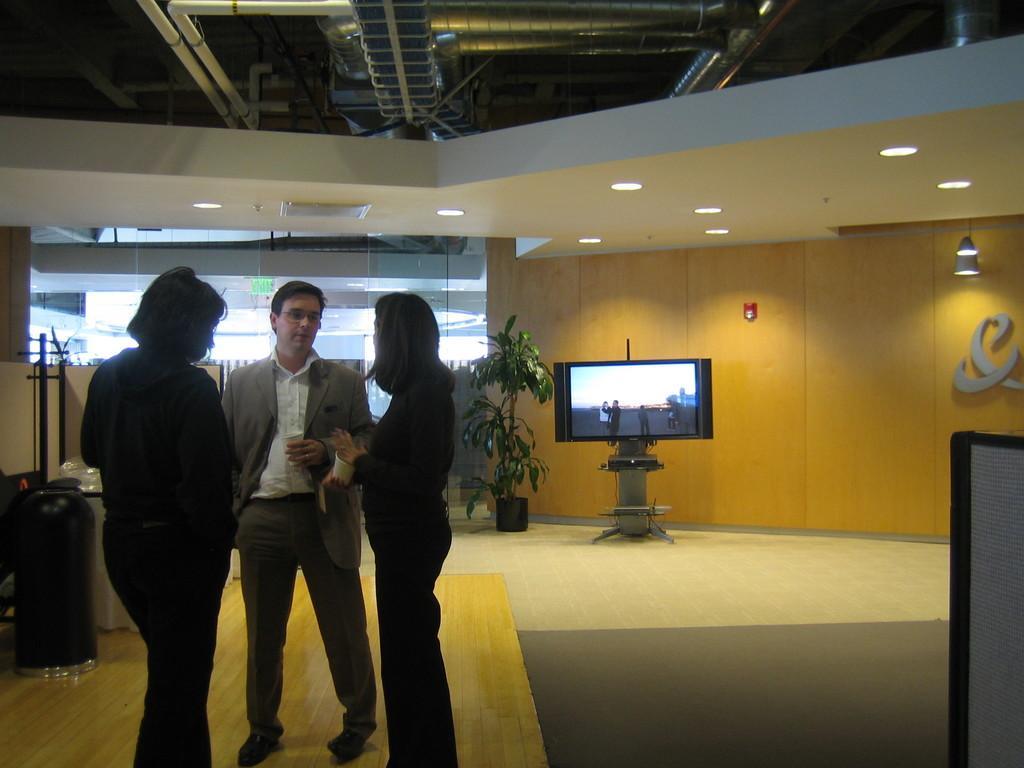Please provide a concise description of this image. In this image we can see three people standing. In the background of the image there is glass. There is a plant. There is a TV. At the bottom of the image there is carpet. At the top of the image there is ceiling with rods. To the left side of the image there are some objects. To the right side of the image there is a text on the wall. 